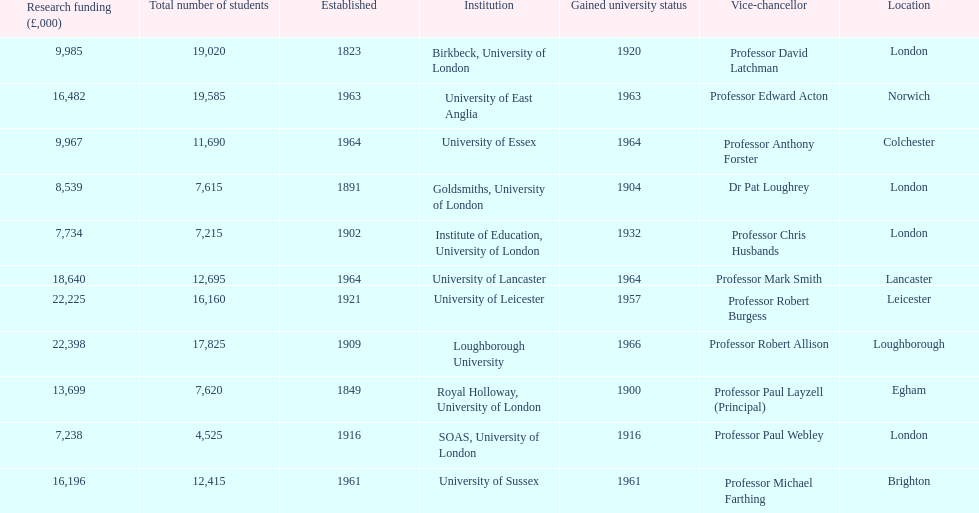Where is birbeck,university of london located? London. Which university was established in 1921? University of Leicester. Which institution gained university status recently? Loughborough University. 